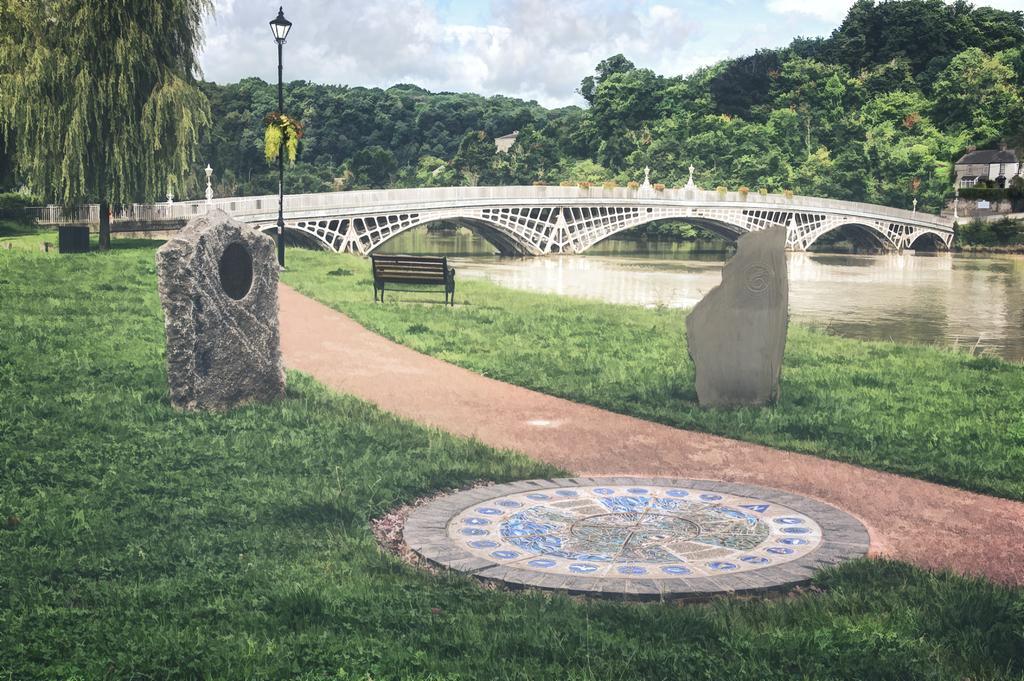Could you give a brief overview of what you see in this image? In this picture we can observe some grass on the ground. There is a black color bench. We can observe a path here. There is a lake and a bridge over the lake. We can observe a black color pole. In the background there are trees and a sky with some clouds. 